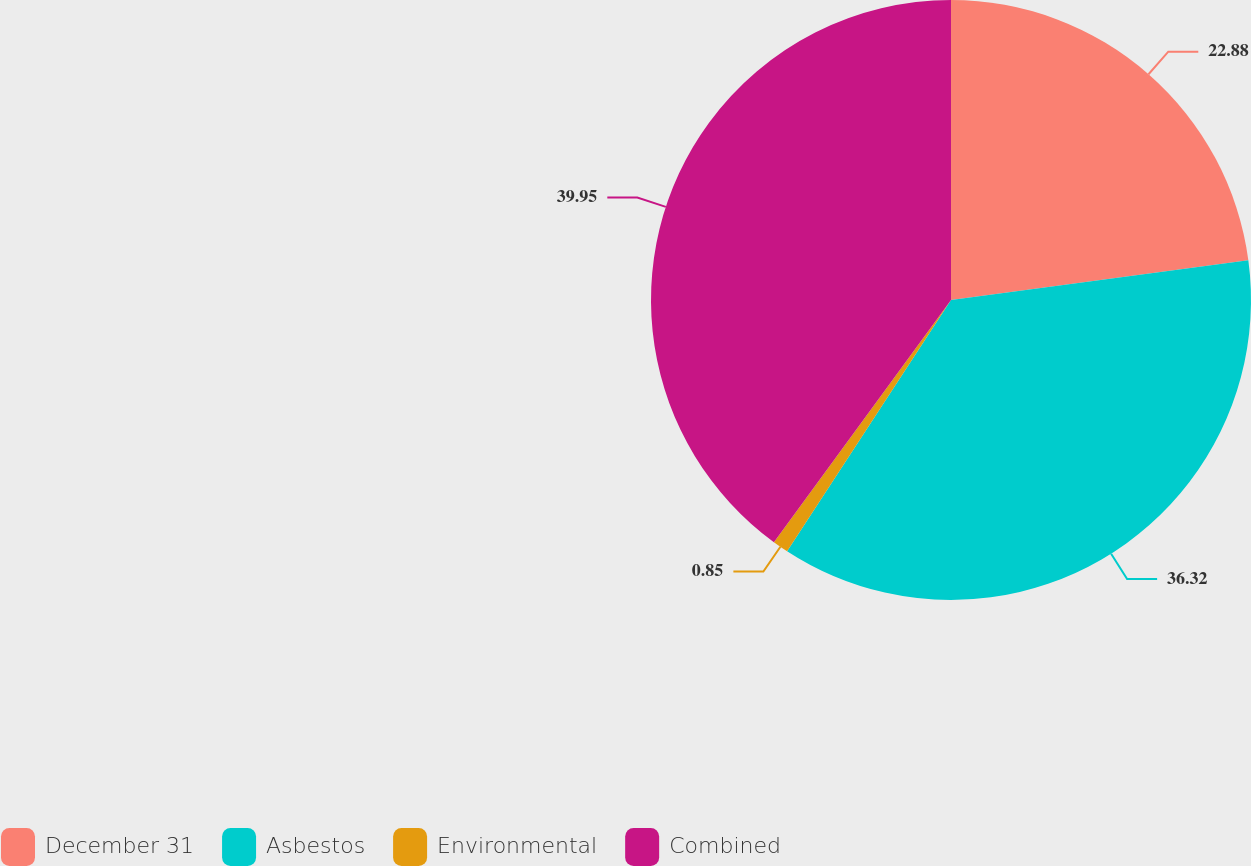<chart> <loc_0><loc_0><loc_500><loc_500><pie_chart><fcel>December 31<fcel>Asbestos<fcel>Environmental<fcel>Combined<nl><fcel>22.88%<fcel>36.32%<fcel>0.85%<fcel>39.95%<nl></chart> 